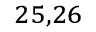Convert formula to latex. <formula><loc_0><loc_0><loc_500><loc_500>^ { 2 5 , 2 6 }</formula> 